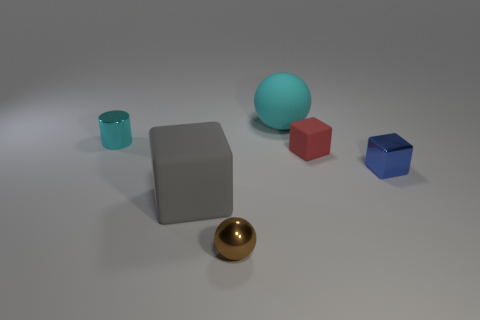Subtract all matte cubes. How many cubes are left? 1 Add 1 cyan cylinders. How many objects exist? 7 Subtract all yellow blocks. Subtract all purple cylinders. How many blocks are left? 3 Subtract all tiny balls. Subtract all brown shiny spheres. How many objects are left? 4 Add 3 gray things. How many gray things are left? 4 Add 4 gray things. How many gray things exist? 5 Subtract 0 green cylinders. How many objects are left? 6 Subtract all spheres. How many objects are left? 4 